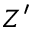Convert formula to latex. <formula><loc_0><loc_0><loc_500><loc_500>Z ^ { \prime }</formula> 